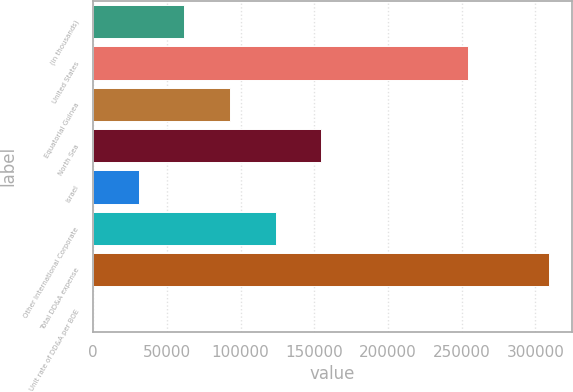Convert chart. <chart><loc_0><loc_0><loc_500><loc_500><bar_chart><fcel>(in thousands)<fcel>United States<fcel>Equatorial Guinea<fcel>North Sea<fcel>Israel<fcel>Other International Corporate<fcel>Total DD&A expense<fcel>Unit rate of DD&A per BOE<nl><fcel>61876<fcel>254041<fcel>92809.3<fcel>154676<fcel>30942.6<fcel>123743<fcel>309343<fcel>9.2<nl></chart> 